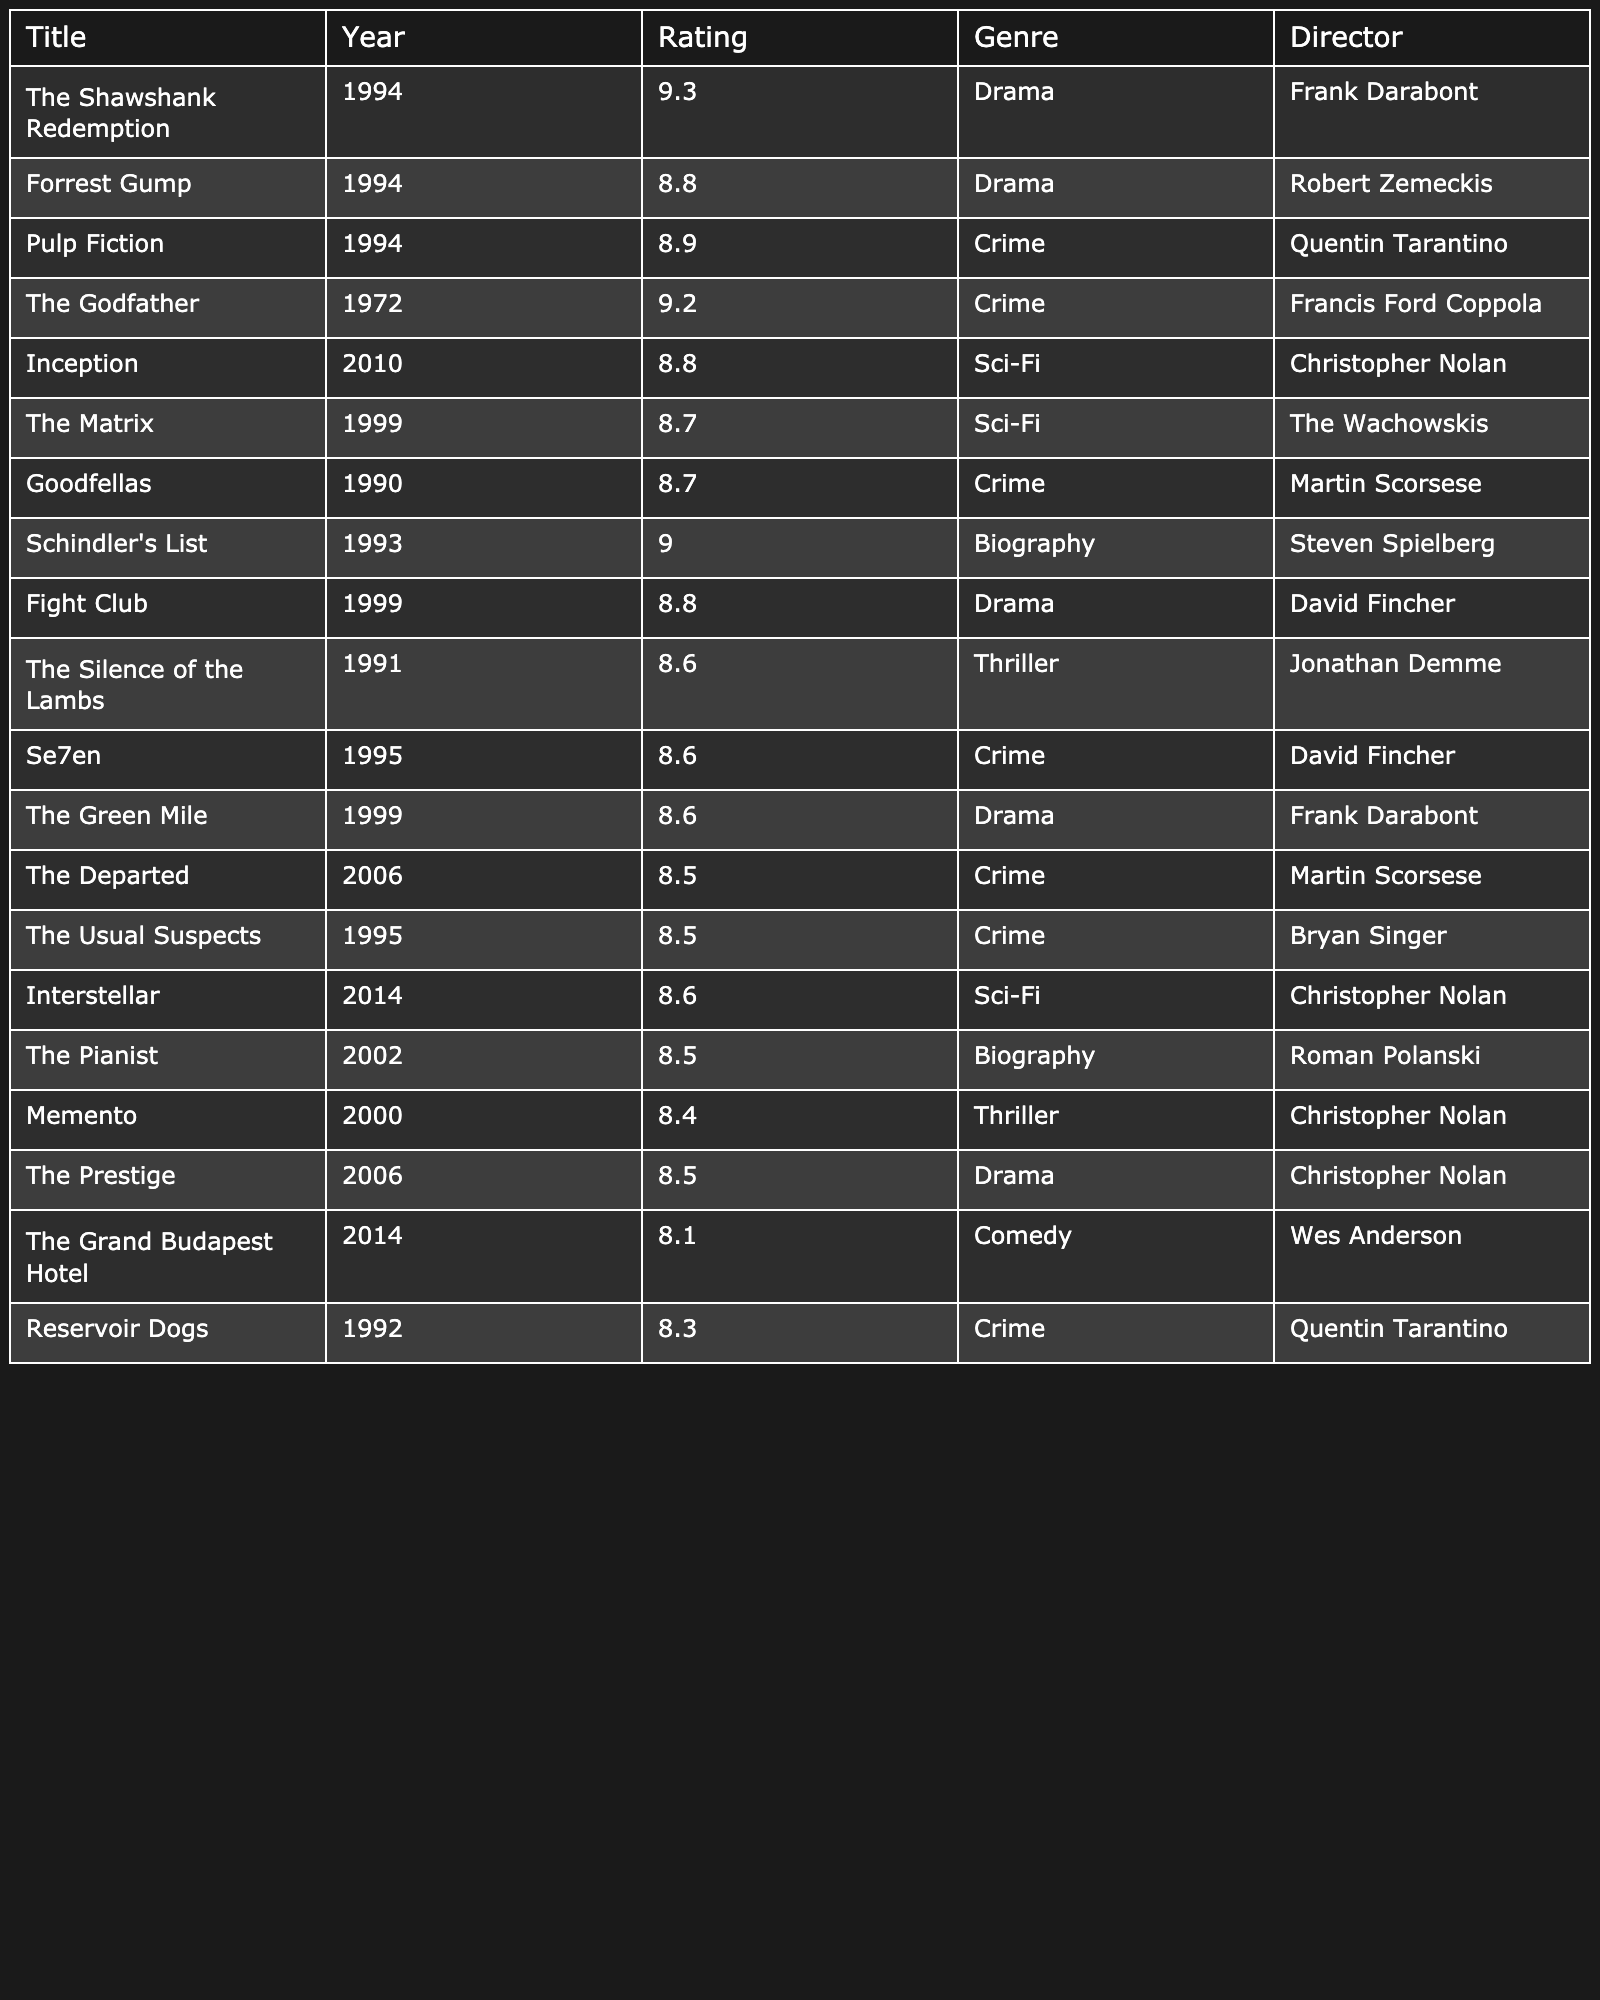What is the highest-rated movie in the table? The table displays viewer ratings, and I can see that "The Shawshank Redemption" has the highest rating of 9.3.
Answer: The Shawshank Redemption How many movies in the table were released in the 1990s? By scanning the "Year" column, I count the movies: The Shawshank Redemption, Forrest Gump, Pulp Fiction, The Matrix, Goodfellas, Schindler's List, Fight Club, The Silence of the Lambs, Se7en, The Green Mile, and Reservoir Dogs, making a total of 11.
Answer: 11 What average rating did the movies directed by Christopher Nolan receive? The movies by Christopher Nolan are Inception, Interstellar, and Memento, with ratings of 8.8, 8.6, and 8.4 respectively. Adding these ratings gives 25.8, and dividing by the number of movies (3) gives an average of 25.8/3 = 8.6.
Answer: 8.6 Is there any movie in the table that has a rating of 9.0 or higher? Looking through the ratings, I see that "The Shawshank Redemption" (9.3) and "Schindler's List" (9.0) are the movies that meet this criterion, meaning there are indeed movies rated 9.0 or higher.
Answer: Yes Which genre has the most movies listed in the table? Scanning the genre, I find that Drama has 6 movies (The Shawshank Redemption, Forrest Gump, Fight Club, The Green Mile, The Prestige), while other genres have fewer entries. Thus, the Drama genre is the most frequent.
Answer: Drama How many movies have a rating below 8.5 in the table? By reviewing the ratings, I find that there are no movies below 8.5 displayed in the table, since the lowest rating recorded is 8.1.
Answer: 0 Which director has directed the most movies in the table? Checking the "Director" column, I count the number of movies: Christopher Nolan (3), Martin Scorsese (2), Quentin Tarantino (2), and others have 1 each. Christopher Nolan has directed the most with 3 films.
Answer: Christopher Nolan What is the difference in rating between the highest-rated movie and the lowest-rated movie in the table? The highest-rated movie is "The Shawshank Redemption" with a rating of 9.3 and the lowest-rated is "The Grand Budapest Hotel" with a rating of 8.1. The difference is 9.3 - 8.1 = 1.2.
Answer: 1.2 How many genres are represented in the table? By reviewing the "Genre" column, I find that Drama, Crime, Sci-Fi, Biography, Thriller, Comedy are the unique genres. Counting these gives a total of 6 different genres represented.
Answer: 6 Which movie from the table was released in 2006? I scan the "Year" column and see two movies from 2006, which are "The Departed" and "The Prestige". Therefore, both belong to that year.
Answer: The Departed, The Prestige What is the median rating of all the movies listed in the table? I first list the ratings: 9.3, 9.2, 9.0, 8.9, 8.8, 8.8, 8.8, 8.7, 8.7, 8.6, 8.6, 8.6, 8.5, 8.5, 8.5, 8.4, 8.3, 8.1. There are 20 ratings, and the median will be the average of the 10th and 11th values, which are both 8.6, so the median rating is 8.6.
Answer: 8.6 